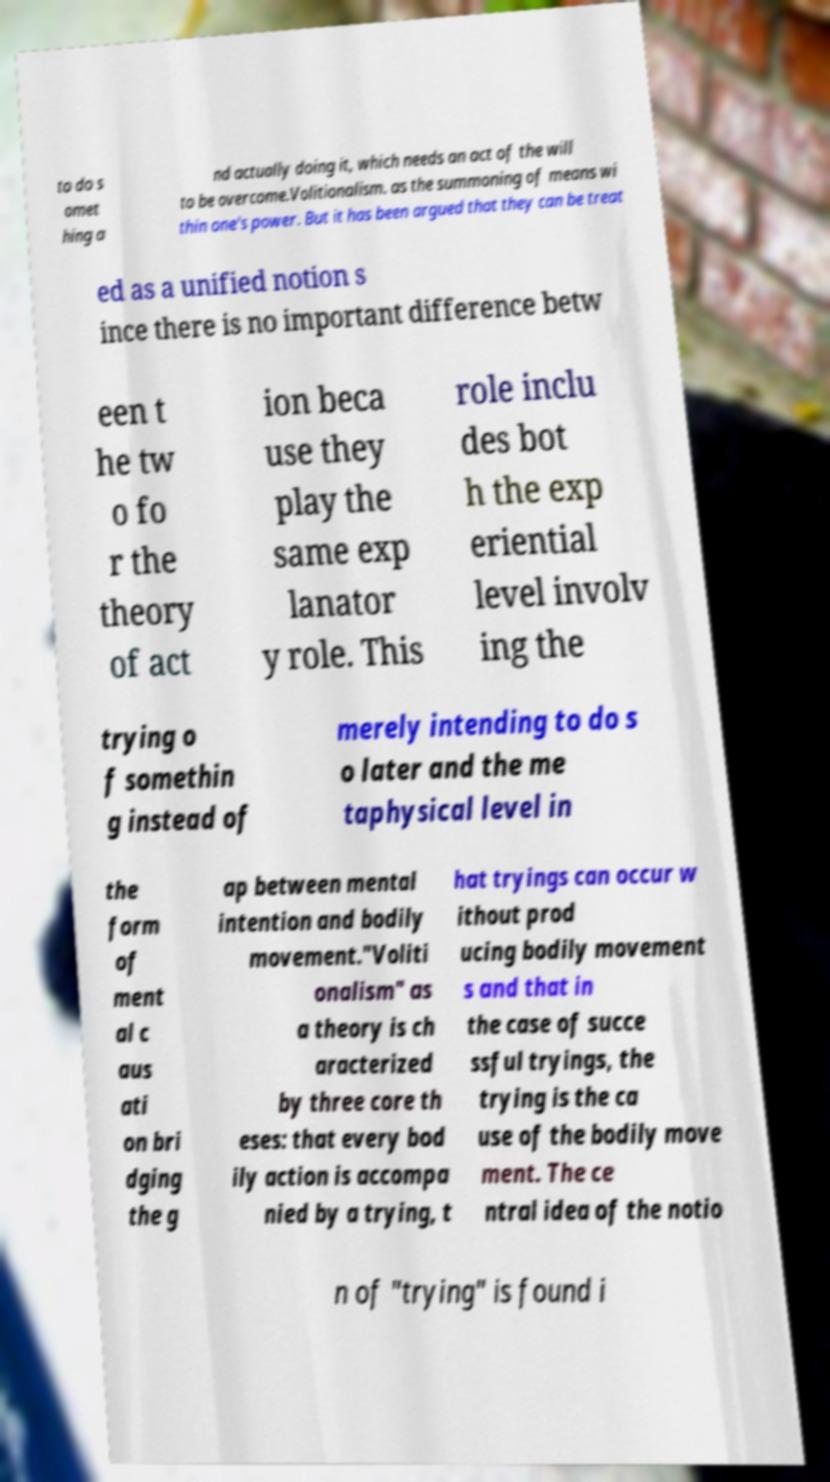Please read and relay the text visible in this image. What does it say? to do s omet hing a nd actually doing it, which needs an act of the will to be overcome.Volitionalism. as the summoning of means wi thin one's power. But it has been argued that they can be treat ed as a unified notion s ince there is no important difference betw een t he tw o fo r the theory of act ion beca use they play the same exp lanator y role. This role inclu des bot h the exp eriential level involv ing the trying o f somethin g instead of merely intending to do s o later and the me taphysical level in the form of ment al c aus ati on bri dging the g ap between mental intention and bodily movement."Voliti onalism" as a theory is ch aracterized by three core th eses: that every bod ily action is accompa nied by a trying, t hat tryings can occur w ithout prod ucing bodily movement s and that in the case of succe ssful tryings, the trying is the ca use of the bodily move ment. The ce ntral idea of the notio n of "trying" is found i 